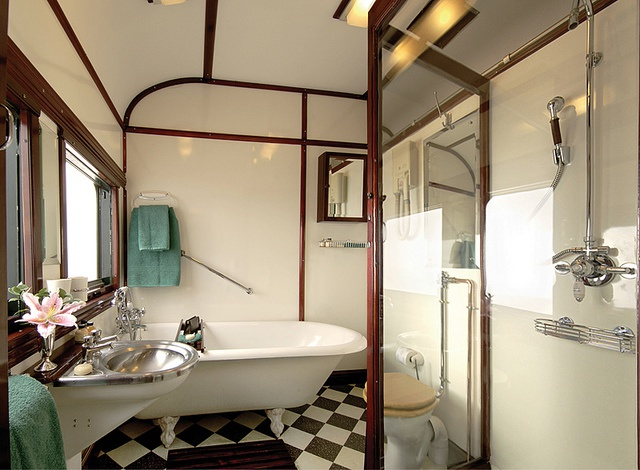Describe the objects in this image and their specific colors. I can see sink in maroon, gray, and darkgray tones, toilet in maroon, tan, gray, and darkgray tones, potted plant in maroon, white, lightpink, and tan tones, and vase in maroon, black, gray, tan, and olive tones in this image. 